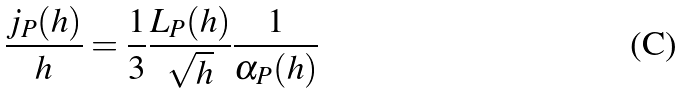Convert formula to latex. <formula><loc_0><loc_0><loc_500><loc_500>\frac { j _ { P } ( h ) } { h } = \frac { 1 } { 3 } \frac { L _ { P } ( h ) } { \sqrt { h } } \frac { 1 } { \alpha _ { P } ( h ) }</formula> 